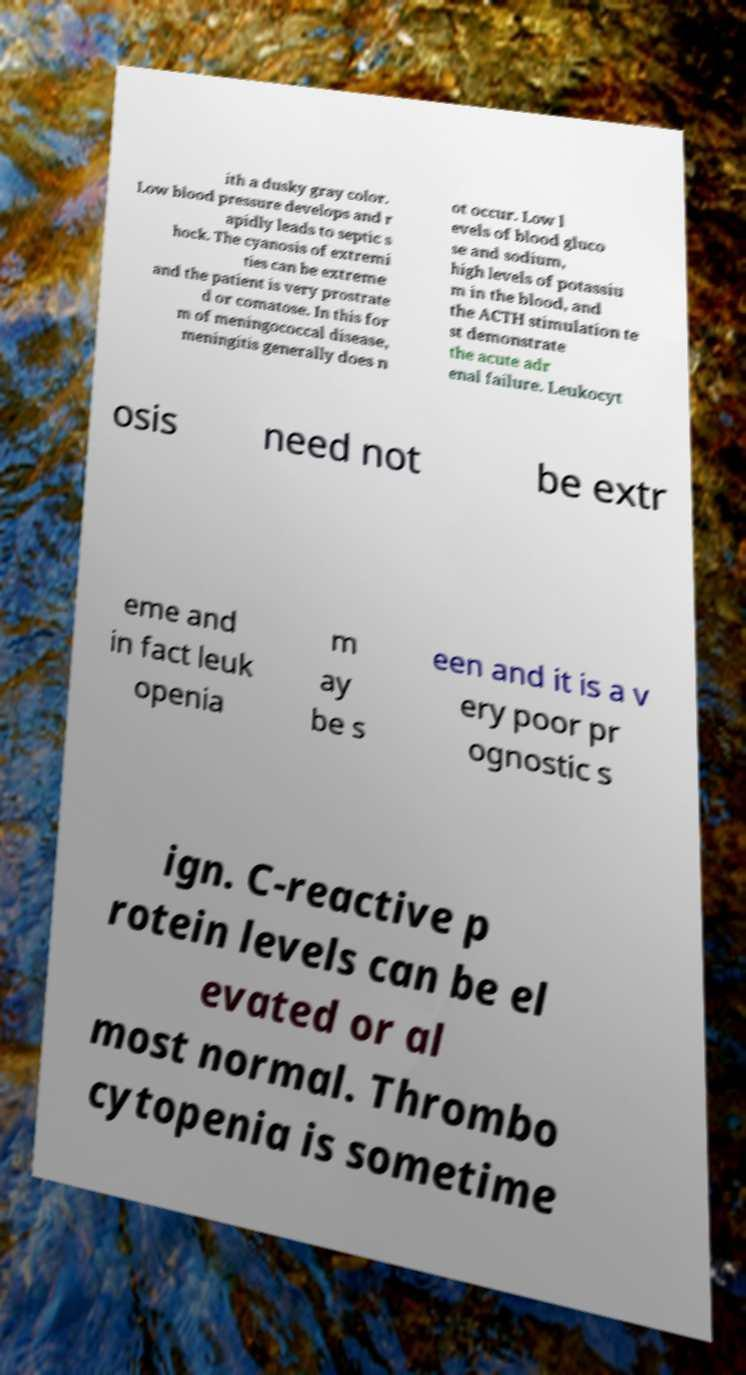What messages or text are displayed in this image? I need them in a readable, typed format. ith a dusky gray color. Low blood pressure develops and r apidly leads to septic s hock. The cyanosis of extremi ties can be extreme and the patient is very prostrate d or comatose. In this for m of meningococcal disease, meningitis generally does n ot occur. Low l evels of blood gluco se and sodium, high levels of potassiu m in the blood, and the ACTH stimulation te st demonstrate the acute adr enal failure. Leukocyt osis need not be extr eme and in fact leuk openia m ay be s een and it is a v ery poor pr ognostic s ign. C-reactive p rotein levels can be el evated or al most normal. Thrombo cytopenia is sometime 